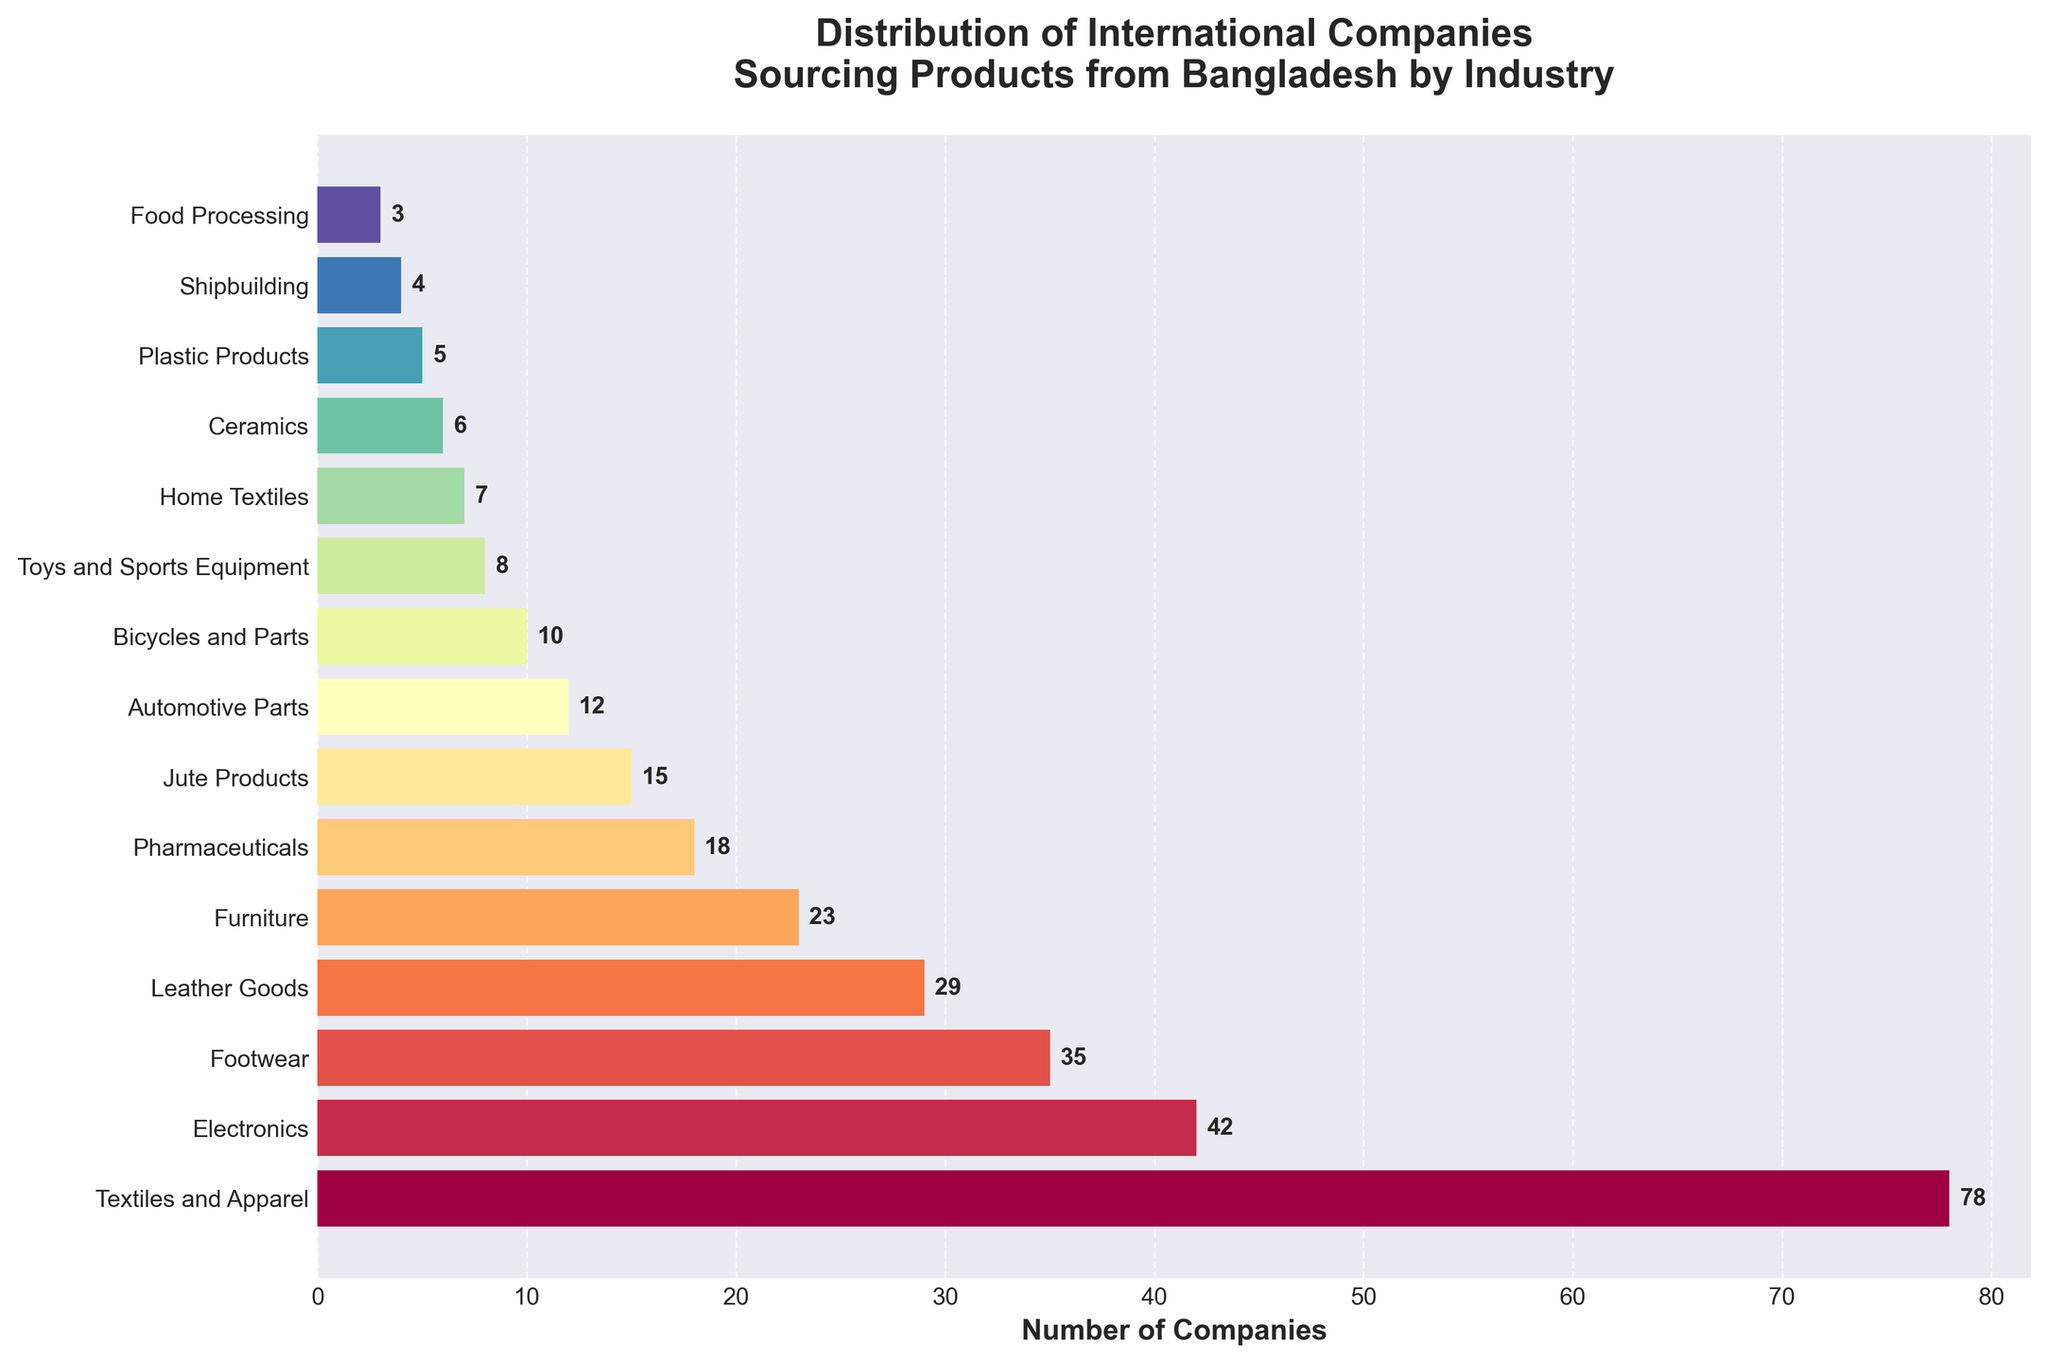Which industry has the highest number of international companies sourcing products from Bangladesh? To determine the industry with the highest number of international companies sourcing products from Bangladesh, identify the bar with the greatest length. In the bar chart, the "Textiles and Apparel" industry has the longest bar with 78 companies.
Answer: Textiles and Apparel What is the difference in the number of companies between the industry with the highest and lowest numbers? Identify the highest value, which is 78 for "Textiles and Apparel," and the lowest value, which is 3 for "Food Processing." Subtract the lowest number from the highest number: 78 - 3 = 75.
Answer: 75 Which industry has more companies: Electronics or Footwear? Compare the length of the bars for "Electronics" (42 companies) and "Footwear" (35 companies). "Electronics" has more companies.
Answer: Electronics How many industries have fewer than 10 companies sourcing products internationally from Bangladesh? Count the bars with lengths less than 10. The industries are Bicycles and Parts (10), Toys and Sports Equipment (8), Home Textiles (7), Ceramics (6), Plastic Products (5), Shipbuilding (4), and Food Processing (3). There are 7 industries.
Answer: 7 What is the sum of the companies in the top three industries? Identify the industries with the highest numbers: Textiles and Apparel (78), Electronics (42), and Footwear (35). Sum these values: 78 + 42 + 35 = 155.
Answer: 155 Which industries have bars colored in the darker spectrum of the color scheme used? Visually inspecting the bar colors, darker hues are usually used for bars close to the center of the color spectrum. The industries in the darker spectrum are likely Electronics, Footwear, and Leather Goods.
Answer: Electronics, Footwear, Leather Goods What is the total number of international companies sourcing products from Bangladesh in all industries combined? Sum the number of companies across all industries: 78 + 42 + 35 + 29 + 23 + 18 + 15 + 12 + 10 + 8 + 7 + 6 + 5 + 4 + 3 = 297.
Answer: 297 By how much does the number of companies in Textiles and Apparel exceed the number in Pharmaceuticals? Identify the numbers for Textiles and Apparel (78) and Pharmaceuticals (18). Subtract 18 from 78: 78 - 18 = 60.
Answer: 60 